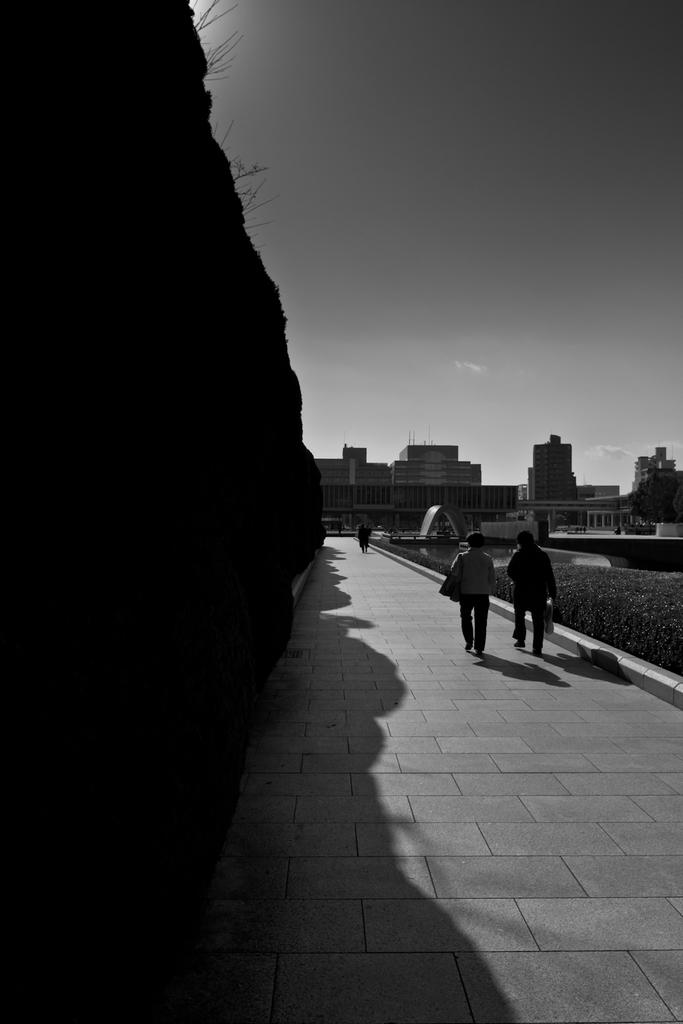What is happening on the ground in the image? There are people on the ground in the image. What can be seen in the distance behind the people? There are buildings, plants, and the sky visible in the background of the image. Can you describe the unspecified objects in the background? Unfortunately, the facts provided do not specify the nature of these objects, so we cannot describe them. What type of animal is the secretary holding in the image? There is no animal or secretary present in the image. 